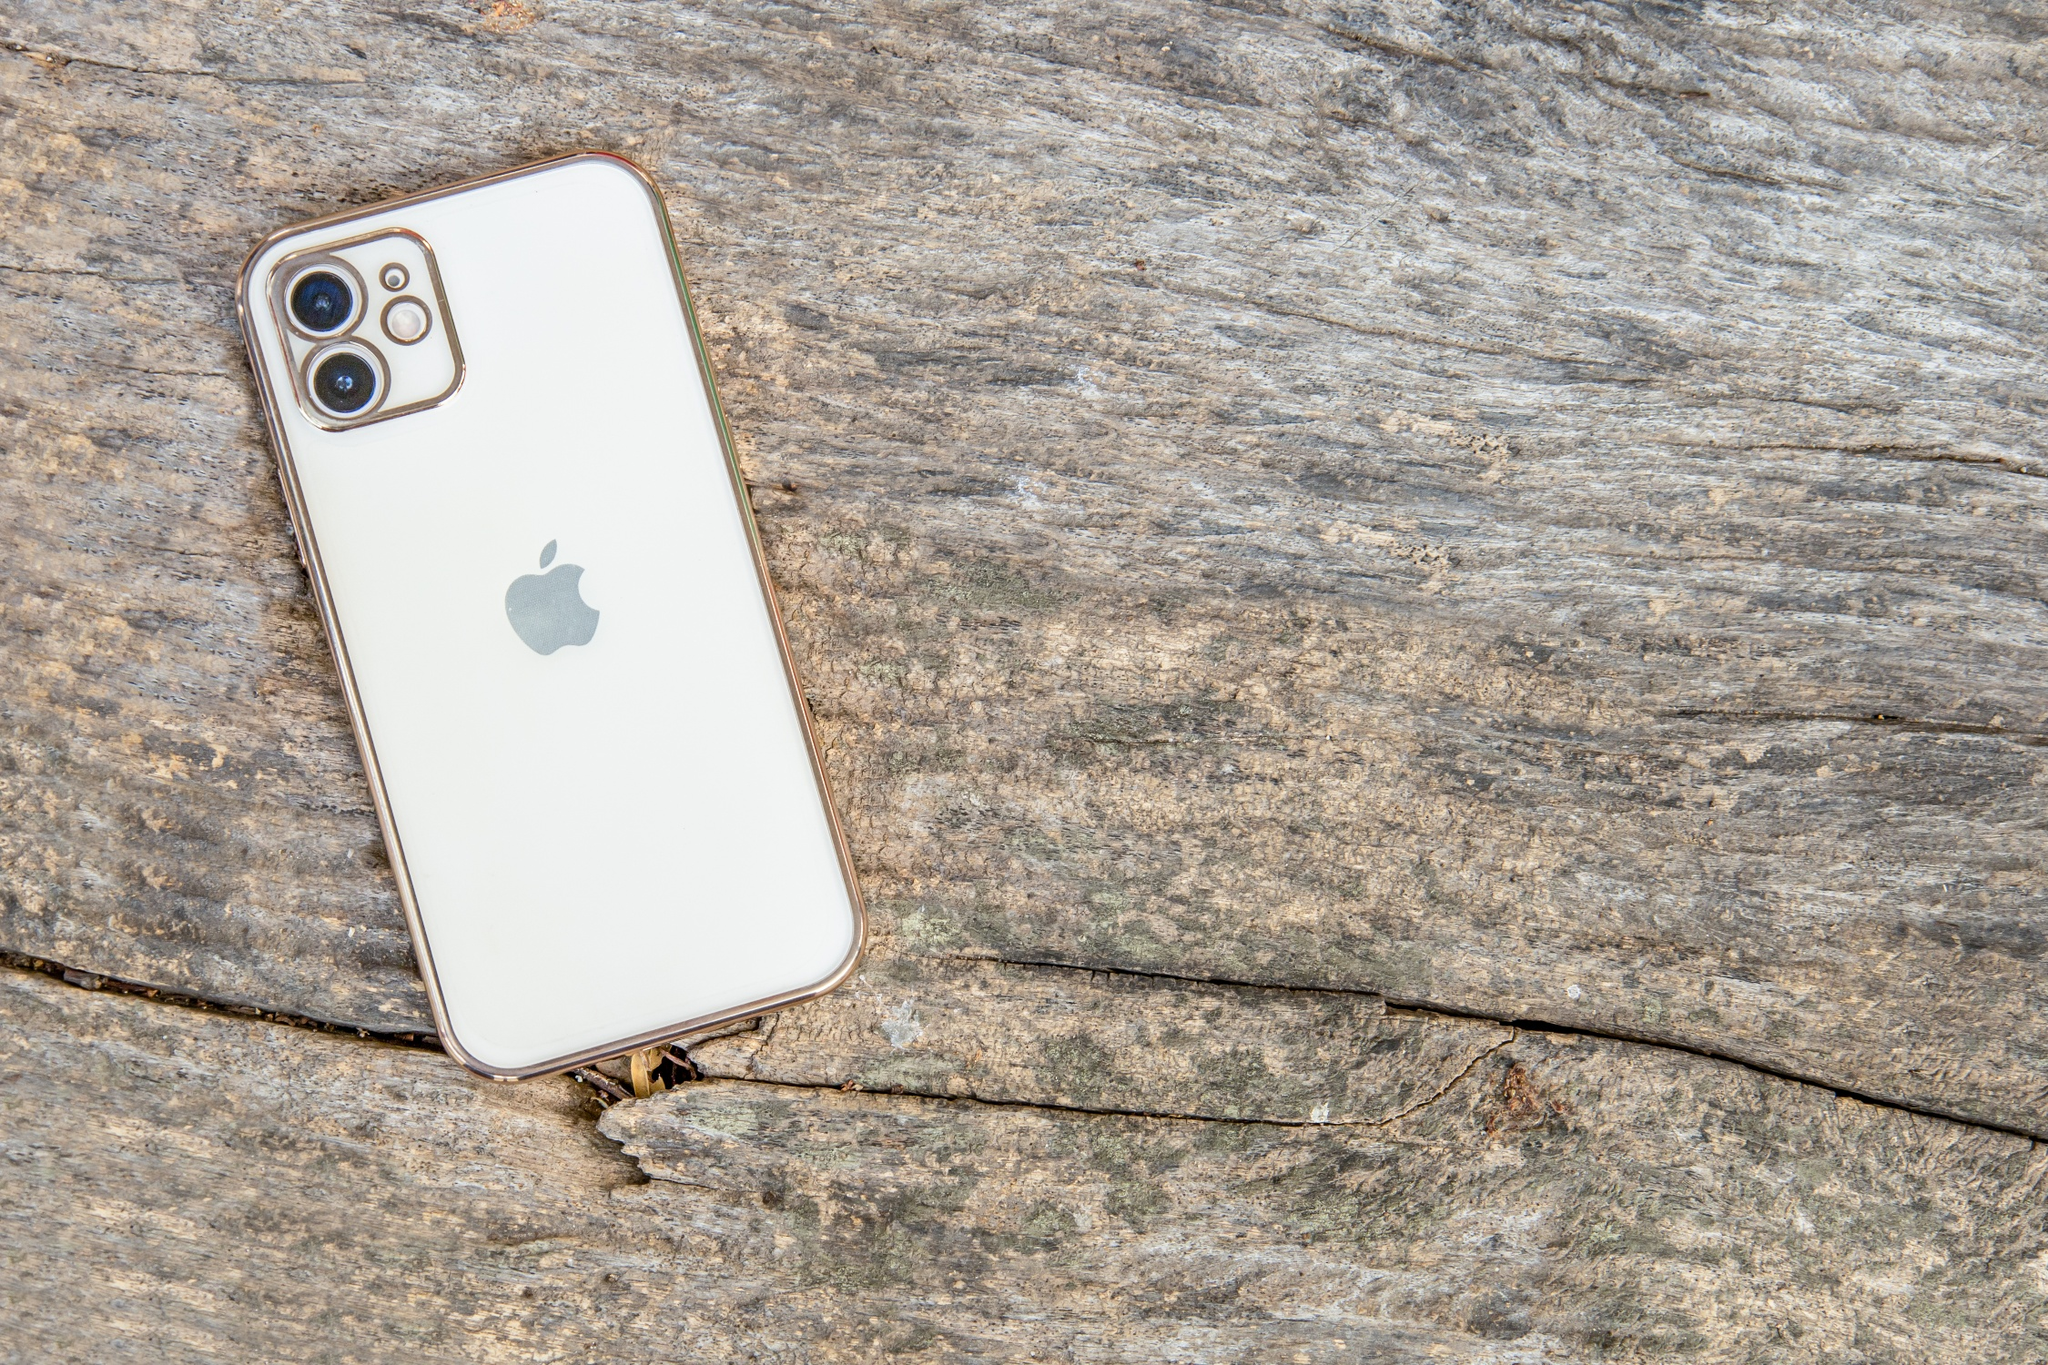Imagine and describe an alternate world where objects like iPhones grow naturally from trees, just like fruits. In an alternate world, technology and nature coexisted in perfect harmony, giving birth to marvels beyond imagination. Picture trees that bore iPhones instead of fruits. These trees, known as 'Tech Trees,' thrived in symbiosis with the environment. Each season, they blossomed with delicate flowers, and by summer, iPhones began to form at the branches. These naturally grown devices were environmentally friendly, with biodegradable components and self-recharging batteries that harnessed solar energy. As the iPhones ripened, they emitted a soft, warm glow, signaling they were ready for harvest. The inhabitants of this world lived sustainably, plucking iPhones from trees and marveling at the seamless blend of nature's wisdom and human ingenuity. This harmonious existence highlighted a deep respect for the environment, redefining the relationship between man and technology. 